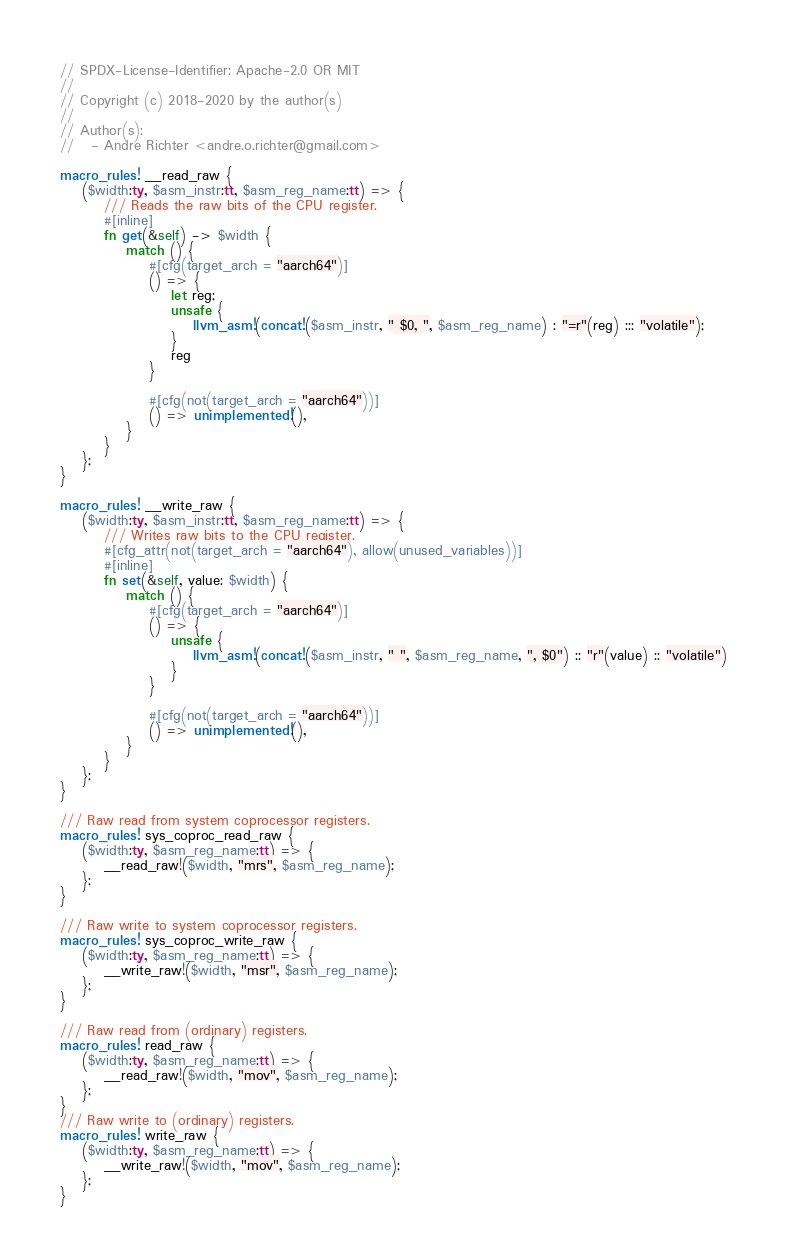Convert code to text. <code><loc_0><loc_0><loc_500><loc_500><_Rust_>// SPDX-License-Identifier: Apache-2.0 OR MIT
//
// Copyright (c) 2018-2020 by the author(s)
//
// Author(s):
//   - Andre Richter <andre.o.richter@gmail.com>

macro_rules! __read_raw {
    ($width:ty, $asm_instr:tt, $asm_reg_name:tt) => {
        /// Reads the raw bits of the CPU register.
        #[inline]
        fn get(&self) -> $width {
            match () {
                #[cfg(target_arch = "aarch64")]
                () => {
                    let reg;
                    unsafe {
                        llvm_asm!(concat!($asm_instr, " $0, ", $asm_reg_name) : "=r"(reg) ::: "volatile");
                    }
                    reg
                }

                #[cfg(not(target_arch = "aarch64"))]
                () => unimplemented!(),
            }
        }
    };
}

macro_rules! __write_raw {
    ($width:ty, $asm_instr:tt, $asm_reg_name:tt) => {
        /// Writes raw bits to the CPU register.
        #[cfg_attr(not(target_arch = "aarch64"), allow(unused_variables))]
        #[inline]
        fn set(&self, value: $width) {
            match () {
                #[cfg(target_arch = "aarch64")]
                () => {
                    unsafe {
                        llvm_asm!(concat!($asm_instr, " ", $asm_reg_name, ", $0") :: "r"(value) :: "volatile")
                    }
                }

                #[cfg(not(target_arch = "aarch64"))]
                () => unimplemented!(),
            }
        }
    };
}

/// Raw read from system coprocessor registers.
macro_rules! sys_coproc_read_raw {
    ($width:ty, $asm_reg_name:tt) => {
        __read_raw!($width, "mrs", $asm_reg_name);
    };
}

/// Raw write to system coprocessor registers.
macro_rules! sys_coproc_write_raw {
    ($width:ty, $asm_reg_name:tt) => {
        __write_raw!($width, "msr", $asm_reg_name);
    };
}

/// Raw read from (ordinary) registers.
macro_rules! read_raw {
    ($width:ty, $asm_reg_name:tt) => {
        __read_raw!($width, "mov", $asm_reg_name);
    };
}
/// Raw write to (ordinary) registers.
macro_rules! write_raw {
    ($width:ty, $asm_reg_name:tt) => {
        __write_raw!($width, "mov", $asm_reg_name);
    };
}
</code> 